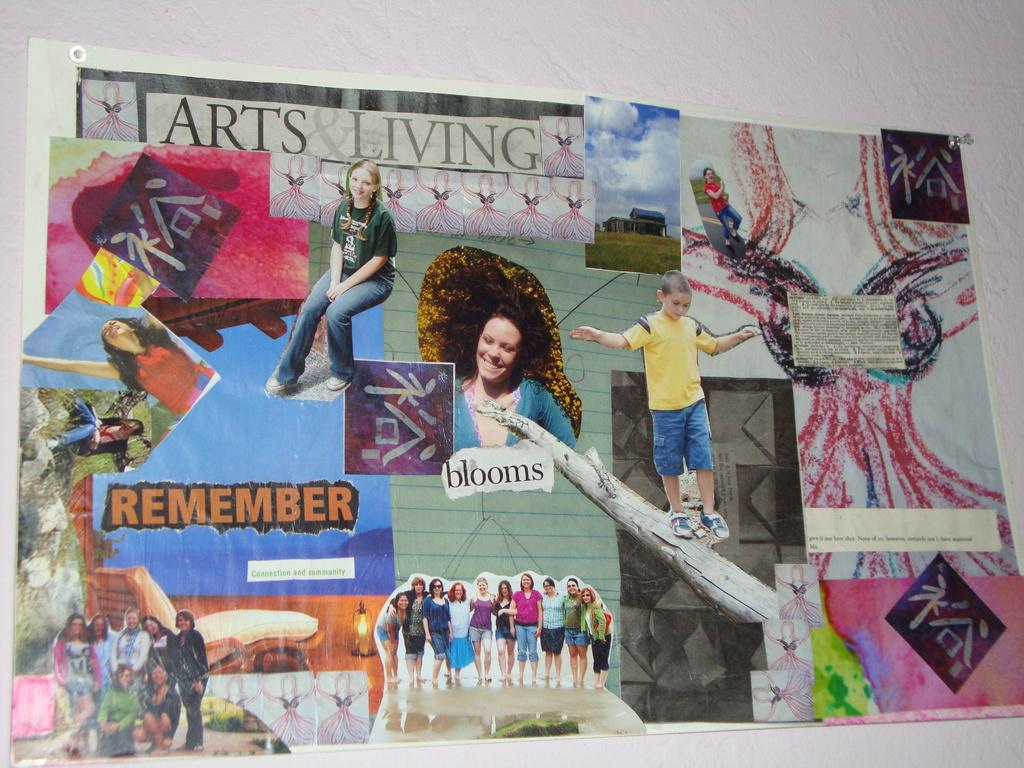<image>
Share a concise interpretation of the image provided. A collage has pictures and the phrase remember on it. 